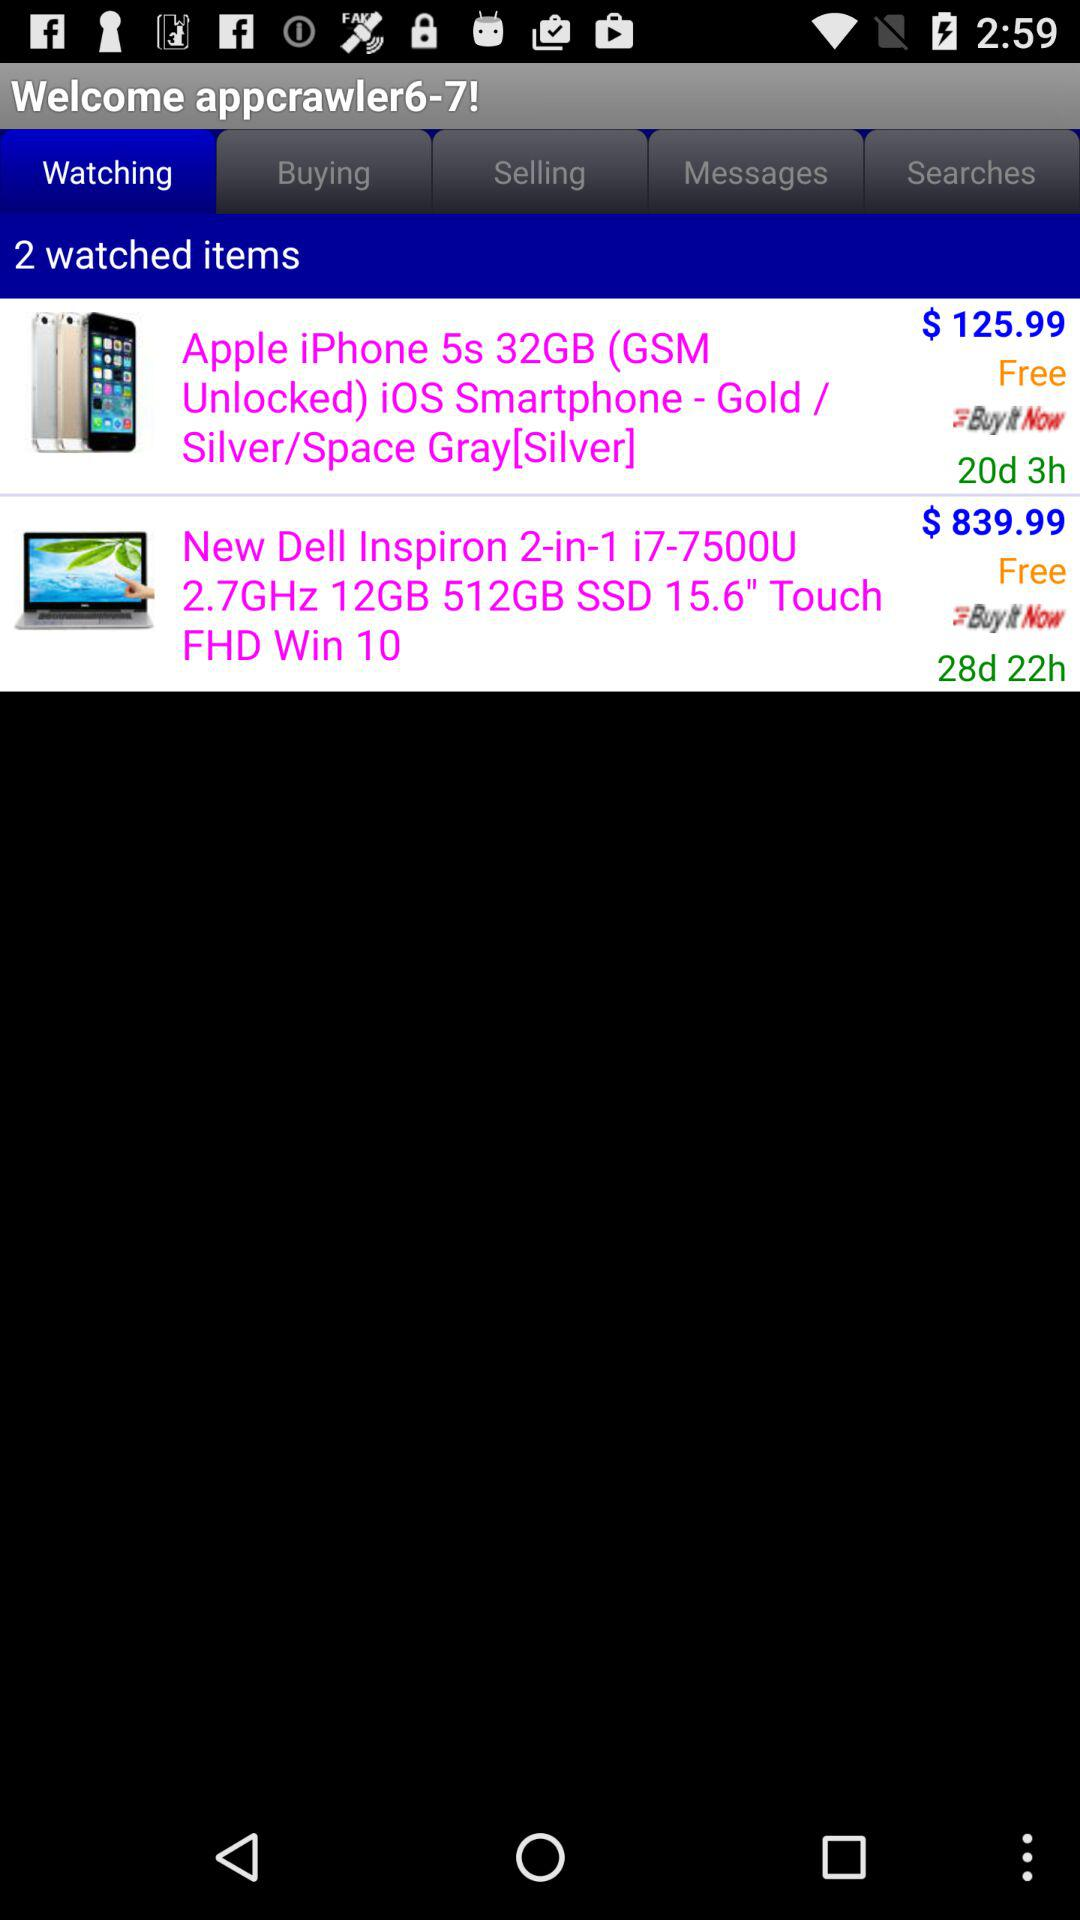What colors of iPhone 5s are available? The iPhone 5s is available in gold, silver, and space gray [silver] colors. 